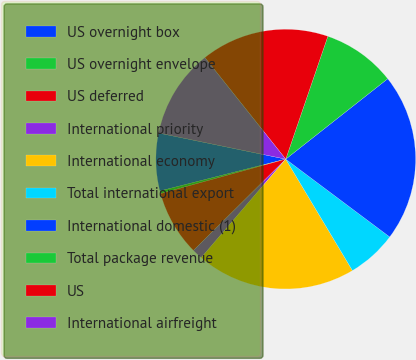Convert chart. <chart><loc_0><loc_0><loc_500><loc_500><pie_chart><fcel>US overnight box<fcel>US overnight envelope<fcel>US deferred<fcel>International priority<fcel>International economy<fcel>Total international export<fcel>International domestic (1)<fcel>Total package revenue<fcel>US<fcel>International airfreight<nl><fcel>7.17%<fcel>0.33%<fcel>8.14%<fcel>1.3%<fcel>19.87%<fcel>6.19%<fcel>20.85%<fcel>9.12%<fcel>15.96%<fcel>11.07%<nl></chart> 